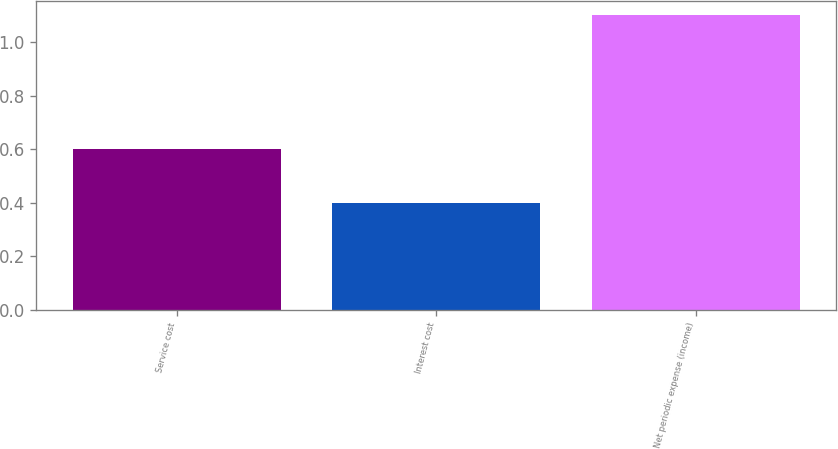Convert chart to OTSL. <chart><loc_0><loc_0><loc_500><loc_500><bar_chart><fcel>Service cost<fcel>Interest cost<fcel>Net periodic expense (income)<nl><fcel>0.6<fcel>0.4<fcel>1.1<nl></chart> 